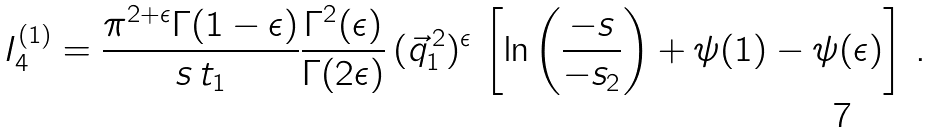Convert formula to latex. <formula><loc_0><loc_0><loc_500><loc_500>I _ { 4 } ^ { ( 1 ) } = \frac { \pi ^ { 2 + \epsilon } \Gamma ( 1 - \epsilon ) } { s \, t _ { 1 } } \frac { \Gamma ^ { 2 } ( \epsilon ) } { \Gamma ( 2 \epsilon ) } \, ( \vec { q } _ { 1 } ^ { \, 2 } ) ^ { \epsilon } \, \left [ \ln \left ( \frac { - s } { - s _ { 2 } } \right ) + \psi ( 1 ) - \psi ( \epsilon ) \right ] \, .</formula> 